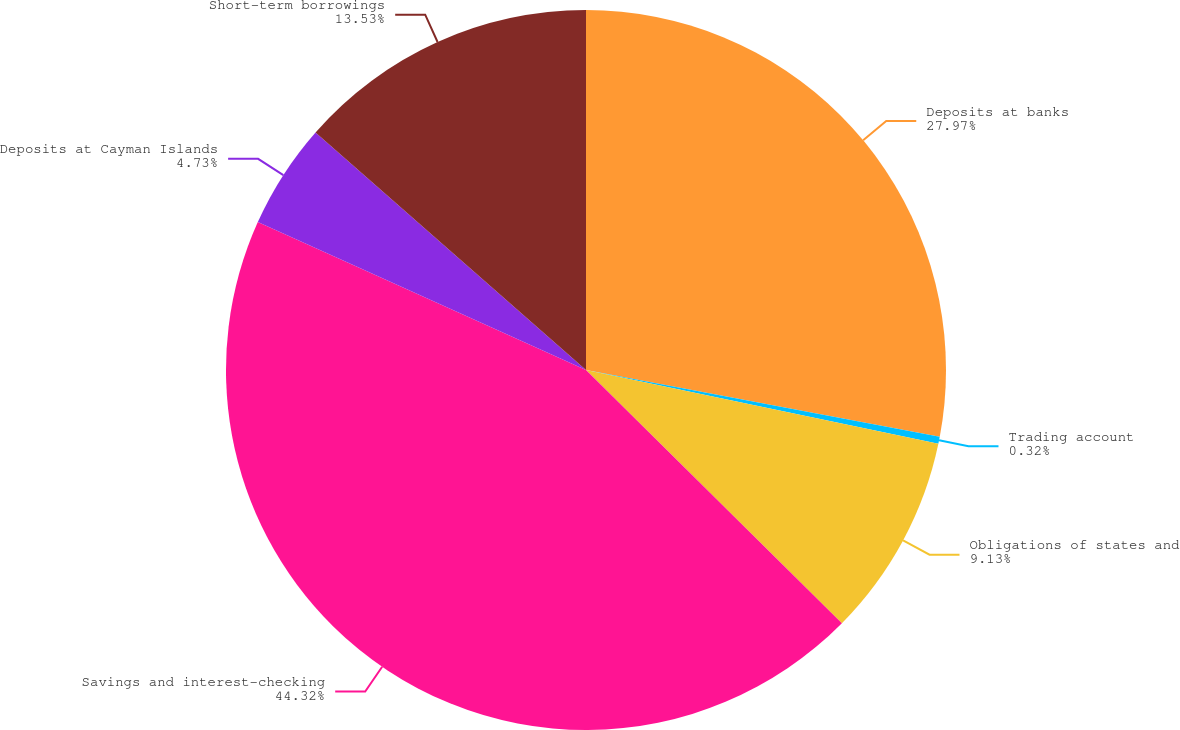<chart> <loc_0><loc_0><loc_500><loc_500><pie_chart><fcel>Deposits at banks<fcel>Trading account<fcel>Obligations of states and<fcel>Savings and interest-checking<fcel>Deposits at Cayman Islands<fcel>Short-term borrowings<nl><fcel>27.97%<fcel>0.32%<fcel>9.13%<fcel>44.33%<fcel>4.73%<fcel>13.53%<nl></chart> 